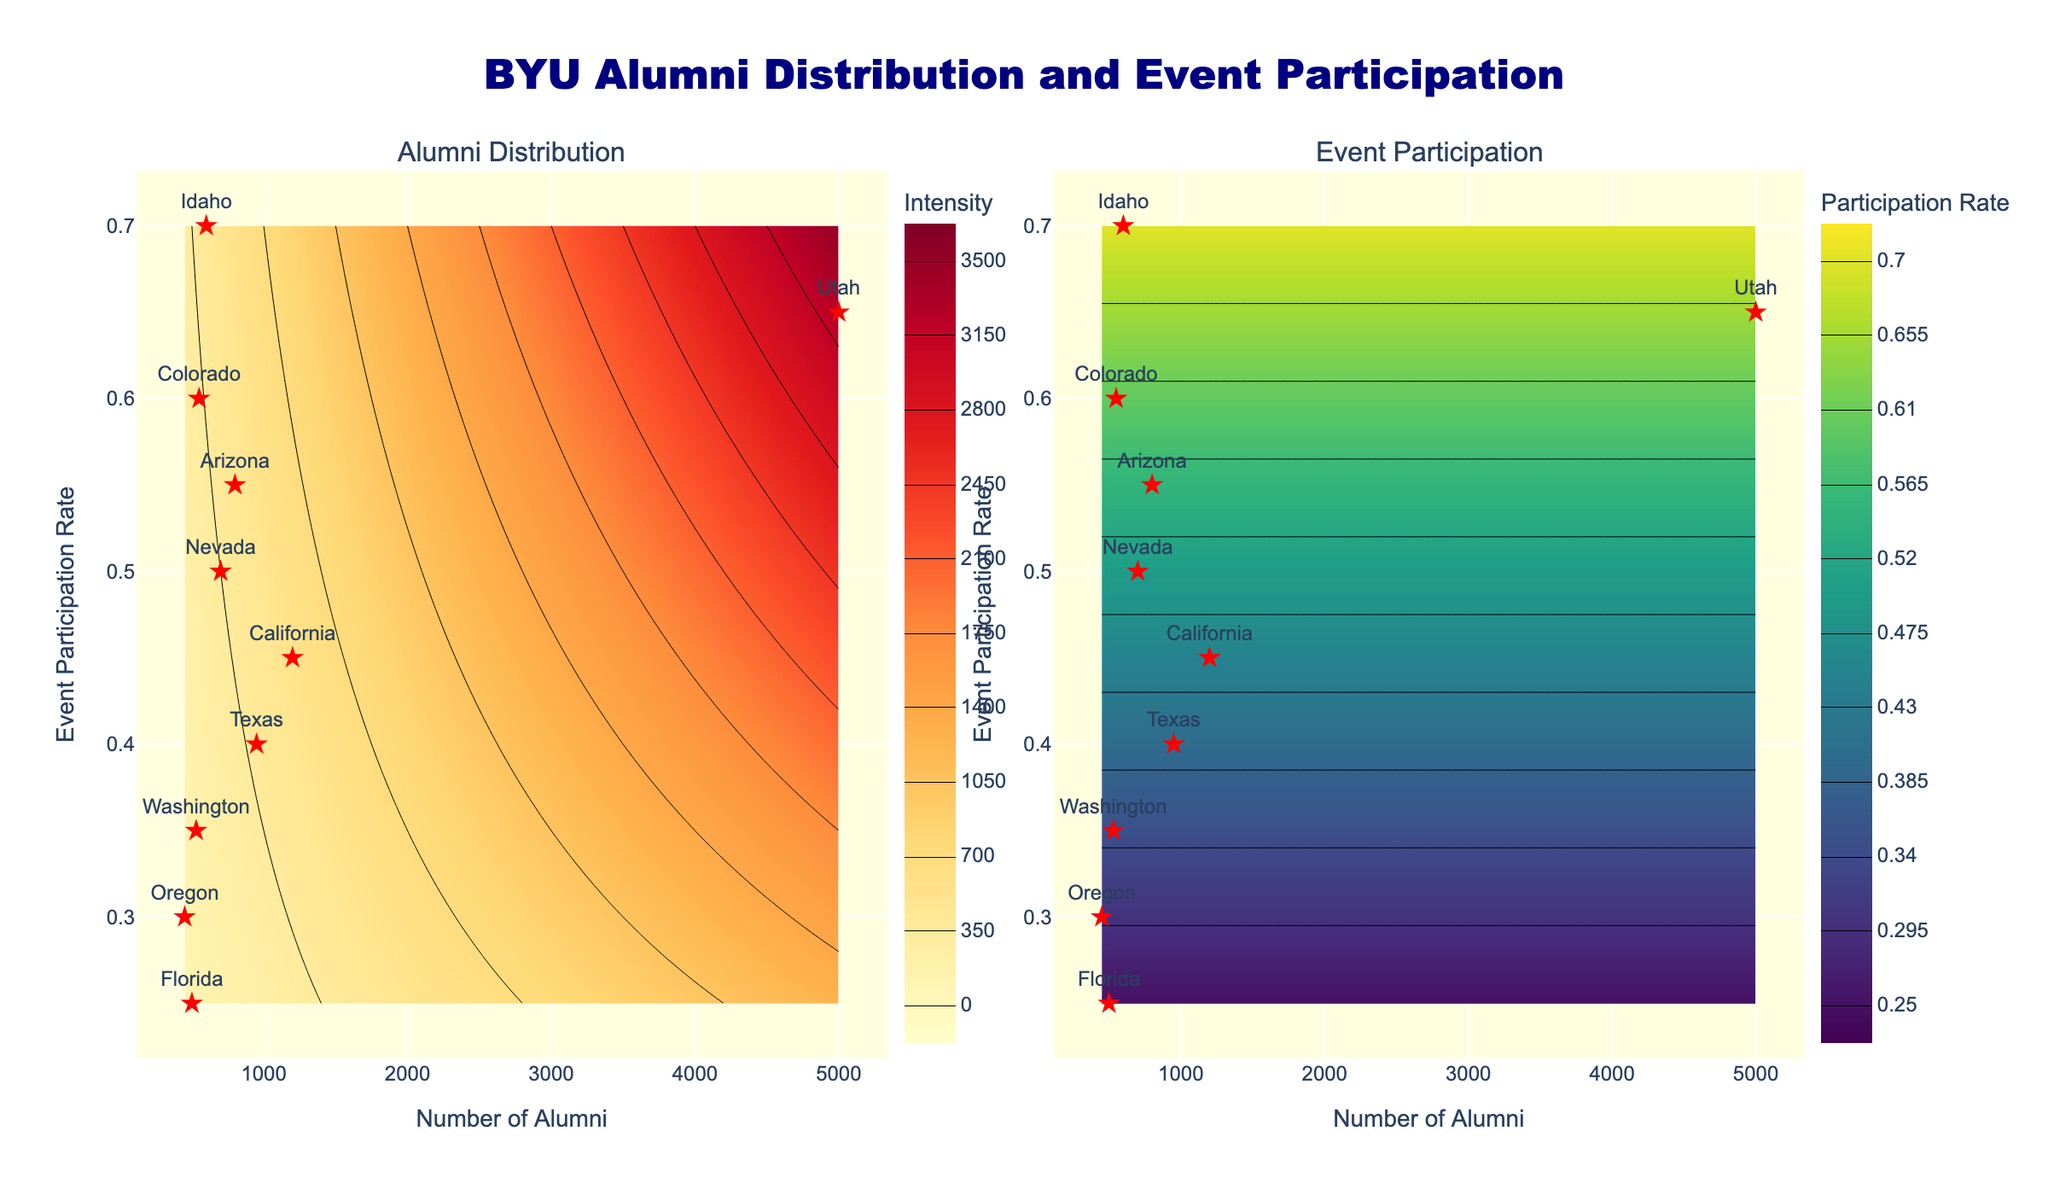What is the title of the figure? The title of the figure is displayed at the top and is in navy color, stating "BYU Alumni Distribution and Event Participation".
Answer: BYU Alumni Distribution and Event Participation What are the x and y-axis labels of the left subplot? The left subplot has its x-axis labeled "Number of Alumni" and its y-axis labeled "Event Participation Rate".
Answer: Number of Alumni, Event Participation Rate Which state has the highest number of alumni? The scatter plot shows each state marked with a red star. The largest value on the x-axis (Number of Alumni) belongs to Utah.
Answer: Utah Which state has the lowest event participation rate? Looking at the y-axis (Event Participation Rate) for the scatter plots, Florida is at the lowest position with a 0.25 rate.
Answer: Florida How does the color gradient of the left subplot relate to the data? The color gradient in the left subplot ranges from yellow to red, representing the intensity of the product of "Number of Alumni" and "Event Participation Rate". Higher values result in darker red colors.
Answer: Higher intensity values are darker red Which color scale is used in the right subplot? The right subplot uses the Viridis color scale, which ranges from purple to yellow-green.
Answer: Viridis What is the participation rate range represented by the contours in the right subplot? The right subplot's contours range from the minimum event participation rate of 0.25 to the maximum of 0.70, with intervals.
Answer: 0.25 to 0.70 Comparatively, which state has more alumni, Idaho or Colorado? On the left scatter plot, Idaho is placed slightly to the right of Colorado, indicating that Idaho has more alumni than Colorado.
Answer: Idaho In general, is there a visible correlation between the number of alumni and their event participation rate? By observing both subplots, we can infer that states with higher numbers of alumni tend to have varying participation rates with no clear linear relationship.
Answer: No clear correlation 